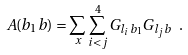<formula> <loc_0><loc_0><loc_500><loc_500>A ( b _ { 1 } b ) = \sum _ { x } \sum _ { i < j } ^ { 4 } G _ { l _ { i } b _ { 1 } } G _ { l _ { j } b } \ .</formula> 